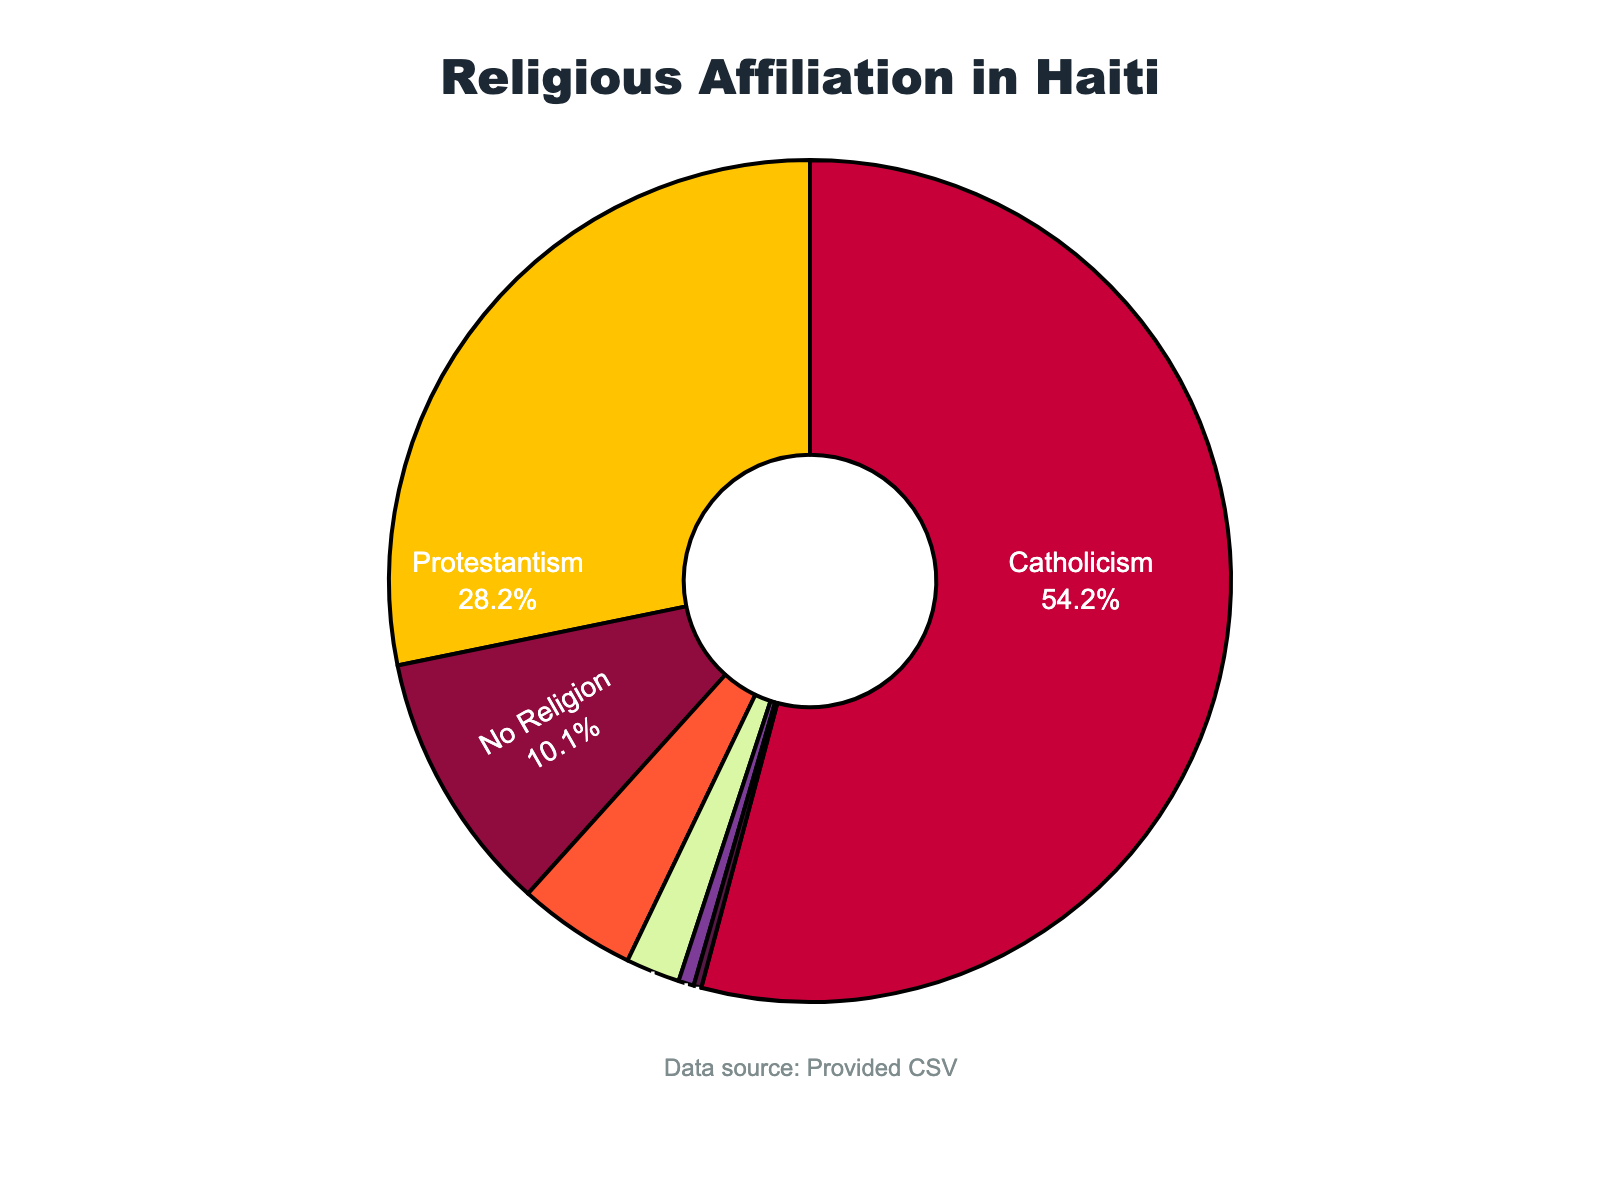What is the percentage of the population in Haiti that practices Catholicism? Look at the pie chart and find the section labeled "Catholicism". The label shows "54.7%".
Answer: 54.7% Which religion has the second-largest proportion of followers in Haiti? Identify the sections with the largest percentages. Catholicism has the largest portion (54.7%), and Protestantism is second with 28.5%.
Answer: Protestantism How many times larger is the Catholic population compared to those with no religion? The Catholic population is 54.7% and those with no religion is 10.2%. Compute the ratio: 54.7 / 10.2 ≈ 5.36.
Answer: About 5.36 times What is the combined percentage of people practicing Protestantism and Other Christian religions? Sum up the percentages for Protestantism (28.5%) and Other Christian (4.6%): 28.5 + 4.6 = 33.1%.
Answer: 33.1% Which religion has the smallest following in Haiti? Find the section with the smallest percentage. Islam has the smallest proportion at 0.3%.
Answer: Islam How does the percentage of Vodou practitioners compare to other religions? Vodou has 2.1%. This is smaller than most other categories except Islam (0.3%) and Other (0.6%).
Answer: Smaller than most What percentage of the population does not adhere to any religion? Look at the chart and find the section labeled "No Religion". The label shows 10.2%.
Answer: 10.2% What is the difference in percentage between those practicing Catholicism and Protestantism? Subtract Protestantism (28.5%) from Catholicism (54.7%): 54.7 - 28.5 = 26.2%.
Answer: 26.2% Which section is represented in green color in the chart? Identify the green section visually. The green section represents the category of Other Christian religions.
Answer: Other Christian 